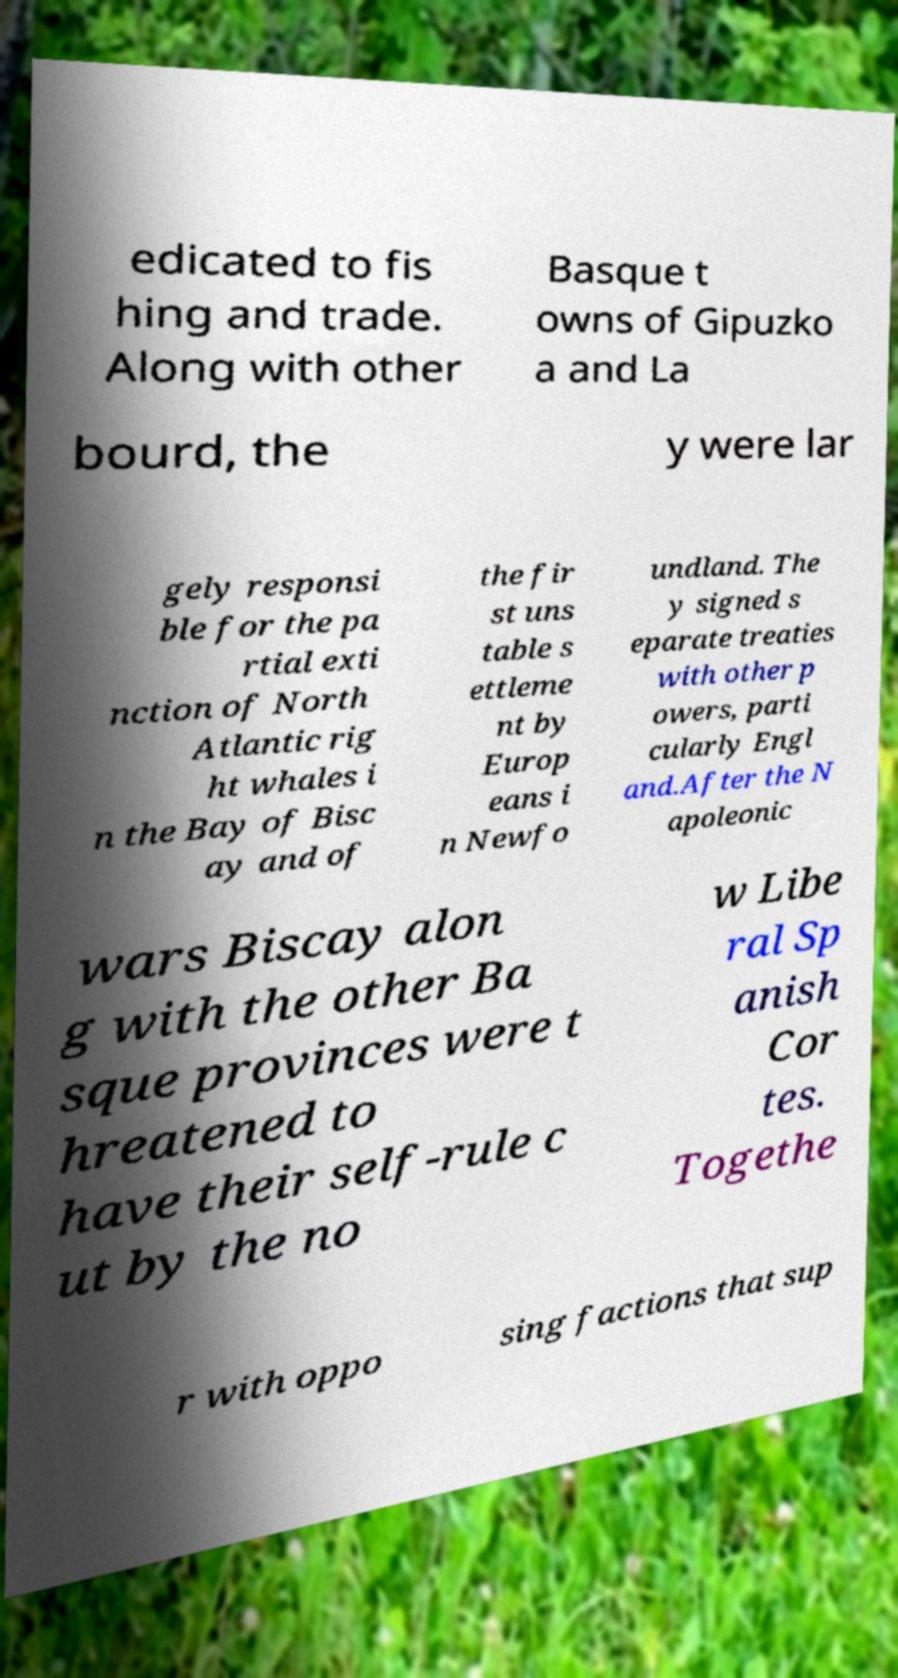Please identify and transcribe the text found in this image. edicated to fis hing and trade. Along with other Basque t owns of Gipuzko a and La bourd, the y were lar gely responsi ble for the pa rtial exti nction of North Atlantic rig ht whales i n the Bay of Bisc ay and of the fir st uns table s ettleme nt by Europ eans i n Newfo undland. The y signed s eparate treaties with other p owers, parti cularly Engl and.After the N apoleonic wars Biscay alon g with the other Ba sque provinces were t hreatened to have their self-rule c ut by the no w Libe ral Sp anish Cor tes. Togethe r with oppo sing factions that sup 